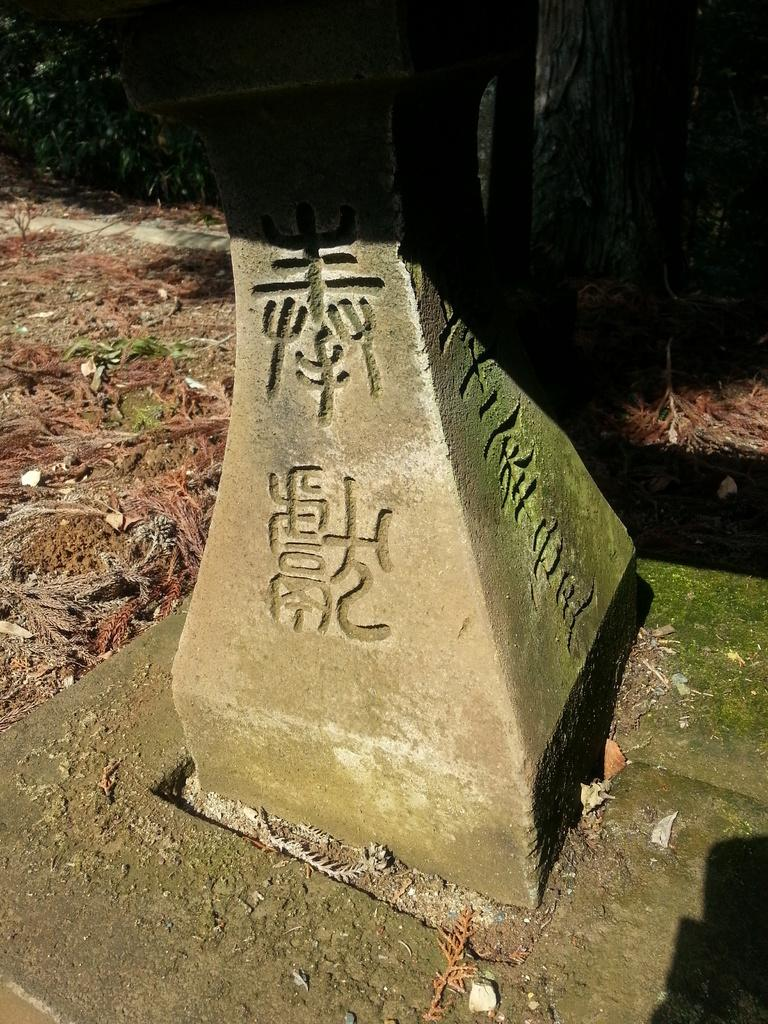What is the main subject of the image? There is a memorial stone in the image. What can be seen at the bottom of the image? The ground is visible at the bottom of the image. What type of vegetation can be seen on the ground in the background of the image? There are dried leaves on the ground in the background of the image. What type of drug is being sold near the memorial stone in the image? There is no indication of any drug or drug-related activity in the image; it features a memorial stone and dried leaves on the ground. 